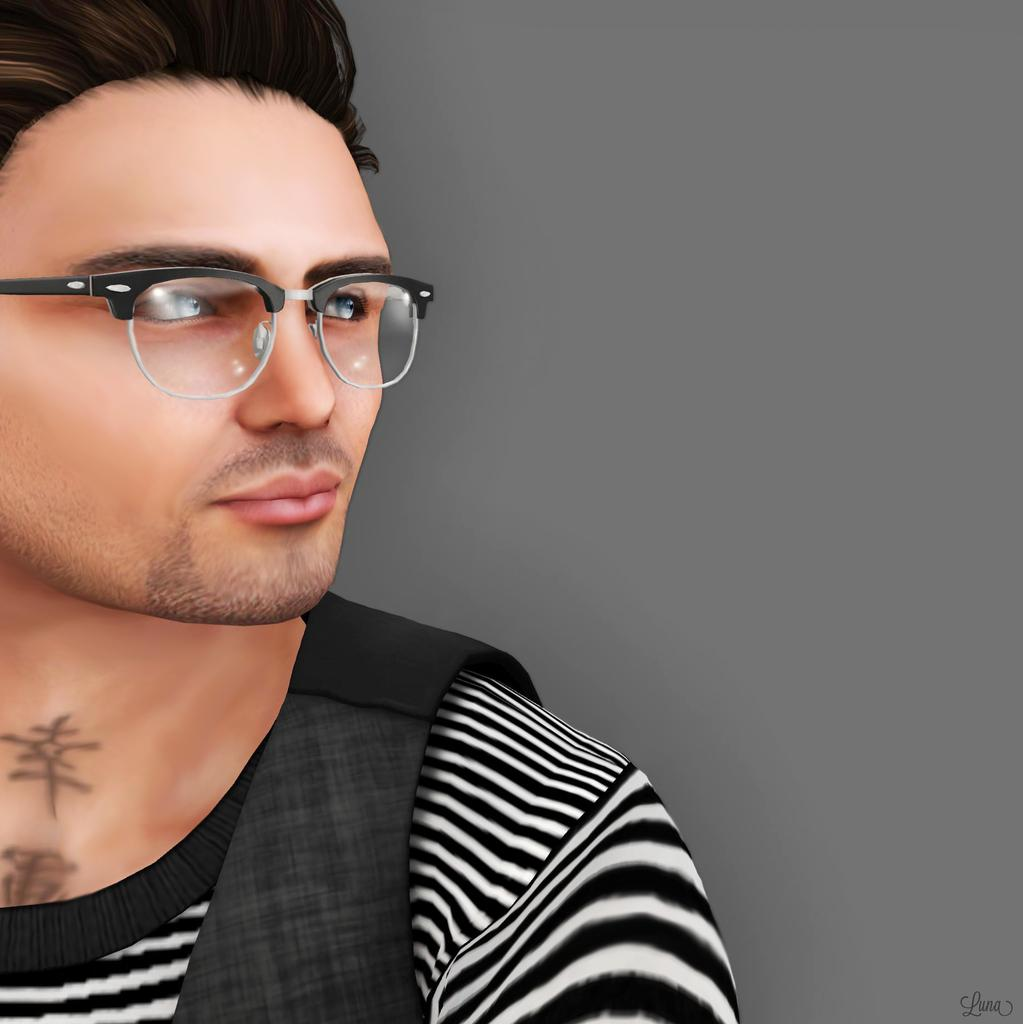What type of image is in the picture? There is a cartoon image of a man in the picture. What can be seen on the man's face in the image? The man is wearing spectacles in the image. What is the setting or background of the image? The background of the image is a plane. Where is the text located in the image? The text is at the bottom right of the image. What type of circle can be seen in the image? There is no circle present in the image. What is the porter doing in the image? There is no porter present in the image. 